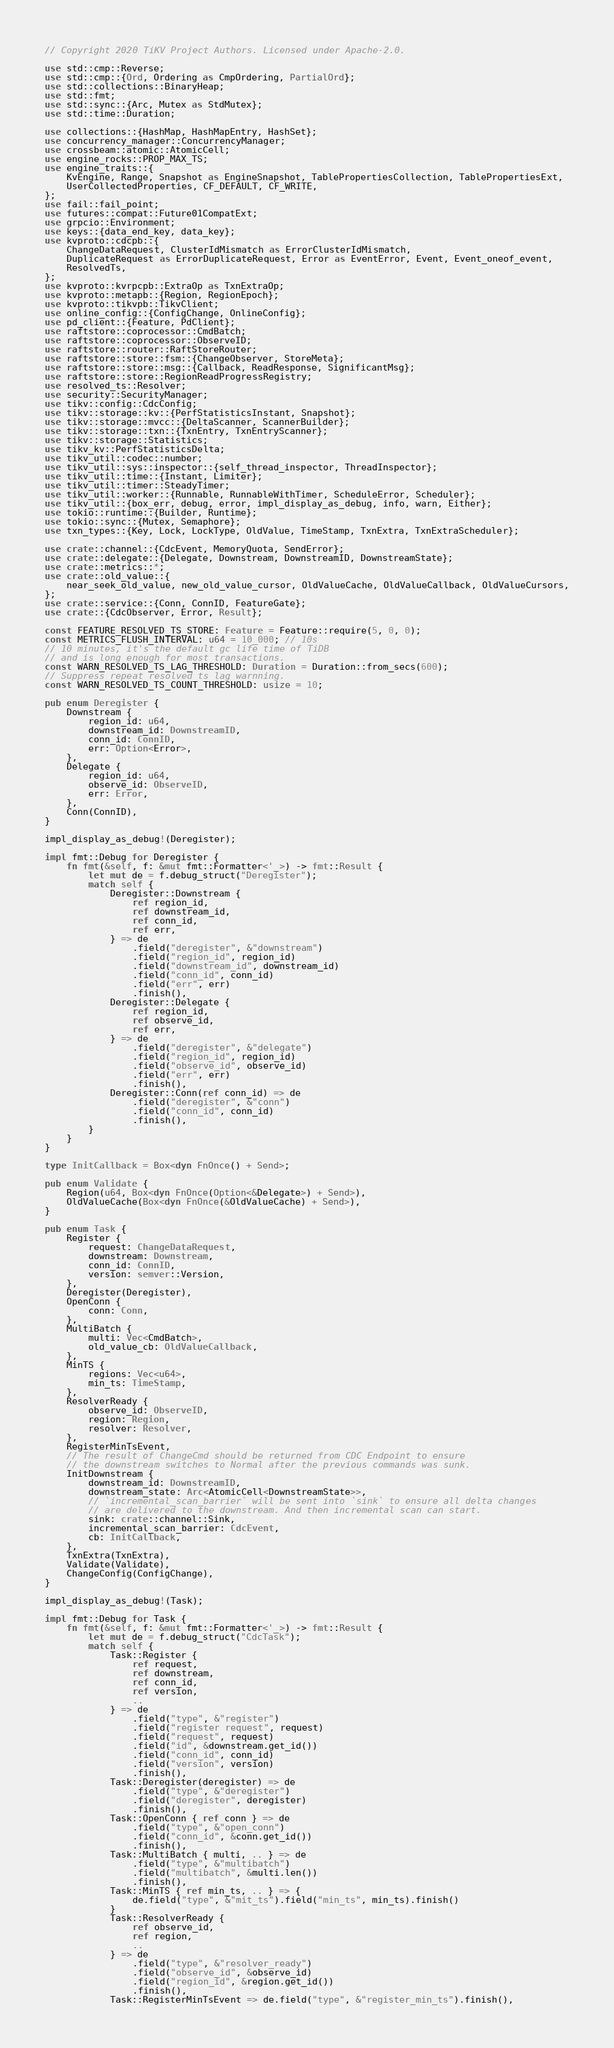Convert code to text. <code><loc_0><loc_0><loc_500><loc_500><_Rust_>// Copyright 2020 TiKV Project Authors. Licensed under Apache-2.0.

use std::cmp::Reverse;
use std::cmp::{Ord, Ordering as CmpOrdering, PartialOrd};
use std::collections::BinaryHeap;
use std::fmt;
use std::sync::{Arc, Mutex as StdMutex};
use std::time::Duration;

use collections::{HashMap, HashMapEntry, HashSet};
use concurrency_manager::ConcurrencyManager;
use crossbeam::atomic::AtomicCell;
use engine_rocks::PROP_MAX_TS;
use engine_traits::{
    KvEngine, Range, Snapshot as EngineSnapshot, TablePropertiesCollection, TablePropertiesExt,
    UserCollectedProperties, CF_DEFAULT, CF_WRITE,
};
use fail::fail_point;
use futures::compat::Future01CompatExt;
use grpcio::Environment;
use keys::{data_end_key, data_key};
use kvproto::cdcpb::{
    ChangeDataRequest, ClusterIdMismatch as ErrorClusterIdMismatch,
    DuplicateRequest as ErrorDuplicateRequest, Error as EventError, Event, Event_oneof_event,
    ResolvedTs,
};
use kvproto::kvrpcpb::ExtraOp as TxnExtraOp;
use kvproto::metapb::{Region, RegionEpoch};
use kvproto::tikvpb::TikvClient;
use online_config::{ConfigChange, OnlineConfig};
use pd_client::{Feature, PdClient};
use raftstore::coprocessor::CmdBatch;
use raftstore::coprocessor::ObserveID;
use raftstore::router::RaftStoreRouter;
use raftstore::store::fsm::{ChangeObserver, StoreMeta};
use raftstore::store::msg::{Callback, ReadResponse, SignificantMsg};
use raftstore::store::RegionReadProgressRegistry;
use resolved_ts::Resolver;
use security::SecurityManager;
use tikv::config::CdcConfig;
use tikv::storage::kv::{PerfStatisticsInstant, Snapshot};
use tikv::storage::mvcc::{DeltaScanner, ScannerBuilder};
use tikv::storage::txn::{TxnEntry, TxnEntryScanner};
use tikv::storage::Statistics;
use tikv_kv::PerfStatisticsDelta;
use tikv_util::codec::number;
use tikv_util::sys::inspector::{self_thread_inspector, ThreadInspector};
use tikv_util::time::{Instant, Limiter};
use tikv_util::timer::SteadyTimer;
use tikv_util::worker::{Runnable, RunnableWithTimer, ScheduleError, Scheduler};
use tikv_util::{box_err, debug, error, impl_display_as_debug, info, warn, Either};
use tokio::runtime::{Builder, Runtime};
use tokio::sync::{Mutex, Semaphore};
use txn_types::{Key, Lock, LockType, OldValue, TimeStamp, TxnExtra, TxnExtraScheduler};

use crate::channel::{CdcEvent, MemoryQuota, SendError};
use crate::delegate::{Delegate, Downstream, DownstreamID, DownstreamState};
use crate::metrics::*;
use crate::old_value::{
    near_seek_old_value, new_old_value_cursor, OldValueCache, OldValueCallback, OldValueCursors,
};
use crate::service::{Conn, ConnID, FeatureGate};
use crate::{CdcObserver, Error, Result};

const FEATURE_RESOLVED_TS_STORE: Feature = Feature::require(5, 0, 0);
const METRICS_FLUSH_INTERVAL: u64 = 10_000; // 10s
// 10 minutes, it's the default gc life time of TiDB
// and is long enough for most transactions.
const WARN_RESOLVED_TS_LAG_THRESHOLD: Duration = Duration::from_secs(600);
// Suppress repeat resolved ts lag warnning.
const WARN_RESOLVED_TS_COUNT_THRESHOLD: usize = 10;

pub enum Deregister {
    Downstream {
        region_id: u64,
        downstream_id: DownstreamID,
        conn_id: ConnID,
        err: Option<Error>,
    },
    Delegate {
        region_id: u64,
        observe_id: ObserveID,
        err: Error,
    },
    Conn(ConnID),
}

impl_display_as_debug!(Deregister);

impl fmt::Debug for Deregister {
    fn fmt(&self, f: &mut fmt::Formatter<'_>) -> fmt::Result {
        let mut de = f.debug_struct("Deregister");
        match self {
            Deregister::Downstream {
                ref region_id,
                ref downstream_id,
                ref conn_id,
                ref err,
            } => de
                .field("deregister", &"downstream")
                .field("region_id", region_id)
                .field("downstream_id", downstream_id)
                .field("conn_id", conn_id)
                .field("err", err)
                .finish(),
            Deregister::Delegate {
                ref region_id,
                ref observe_id,
                ref err,
            } => de
                .field("deregister", &"delegate")
                .field("region_id", region_id)
                .field("observe_id", observe_id)
                .field("err", err)
                .finish(),
            Deregister::Conn(ref conn_id) => de
                .field("deregister", &"conn")
                .field("conn_id", conn_id)
                .finish(),
        }
    }
}

type InitCallback = Box<dyn FnOnce() + Send>;

pub enum Validate {
    Region(u64, Box<dyn FnOnce(Option<&Delegate>) + Send>),
    OldValueCache(Box<dyn FnOnce(&OldValueCache) + Send>),
}

pub enum Task {
    Register {
        request: ChangeDataRequest,
        downstream: Downstream,
        conn_id: ConnID,
        version: semver::Version,
    },
    Deregister(Deregister),
    OpenConn {
        conn: Conn,
    },
    MultiBatch {
        multi: Vec<CmdBatch>,
        old_value_cb: OldValueCallback,
    },
    MinTS {
        regions: Vec<u64>,
        min_ts: TimeStamp,
    },
    ResolverReady {
        observe_id: ObserveID,
        region: Region,
        resolver: Resolver,
    },
    RegisterMinTsEvent,
    // The result of ChangeCmd should be returned from CDC Endpoint to ensure
    // the downstream switches to Normal after the previous commands was sunk.
    InitDownstream {
        downstream_id: DownstreamID,
        downstream_state: Arc<AtomicCell<DownstreamState>>,
        // `incremental_scan_barrier` will be sent into `sink` to ensure all delta changes
        // are delivered to the downstream. And then incremental scan can start.
        sink: crate::channel::Sink,
        incremental_scan_barrier: CdcEvent,
        cb: InitCallback,
    },
    TxnExtra(TxnExtra),
    Validate(Validate),
    ChangeConfig(ConfigChange),
}

impl_display_as_debug!(Task);

impl fmt::Debug for Task {
    fn fmt(&self, f: &mut fmt::Formatter<'_>) -> fmt::Result {
        let mut de = f.debug_struct("CdcTask");
        match self {
            Task::Register {
                ref request,
                ref downstream,
                ref conn_id,
                ref version,
                ..
            } => de
                .field("type", &"register")
                .field("register request", request)
                .field("request", request)
                .field("id", &downstream.get_id())
                .field("conn_id", conn_id)
                .field("version", version)
                .finish(),
            Task::Deregister(deregister) => de
                .field("type", &"deregister")
                .field("deregister", deregister)
                .finish(),
            Task::OpenConn { ref conn } => de
                .field("type", &"open_conn")
                .field("conn_id", &conn.get_id())
                .finish(),
            Task::MultiBatch { multi, .. } => de
                .field("type", &"multibatch")
                .field("multibatch", &multi.len())
                .finish(),
            Task::MinTS { ref min_ts, .. } => {
                de.field("type", &"mit_ts").field("min_ts", min_ts).finish()
            }
            Task::ResolverReady {
                ref observe_id,
                ref region,
                ..
            } => de
                .field("type", &"resolver_ready")
                .field("observe_id", &observe_id)
                .field("region_id", &region.get_id())
                .finish(),
            Task::RegisterMinTsEvent => de.field("type", &"register_min_ts").finish(),</code> 